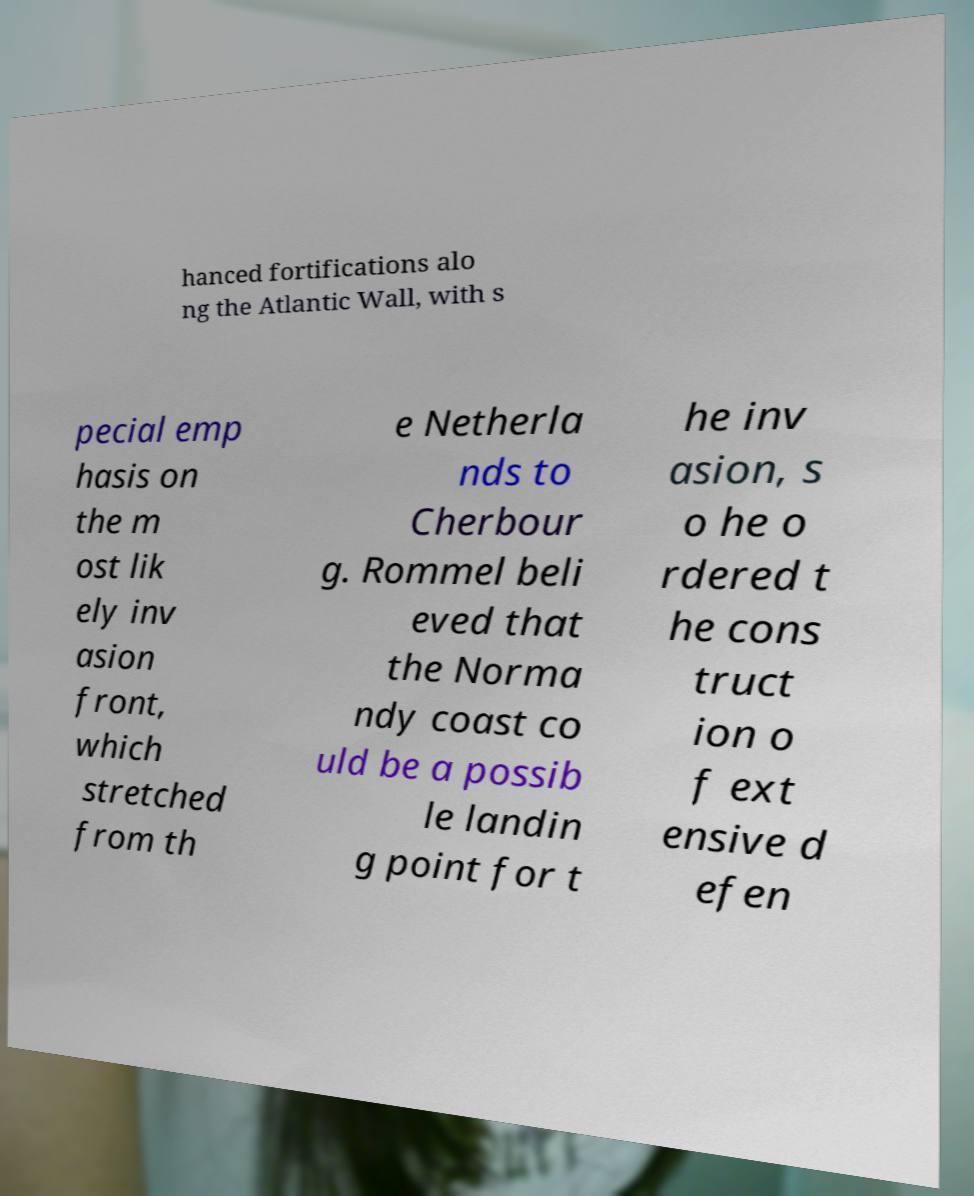Can you accurately transcribe the text from the provided image for me? hanced fortifications alo ng the Atlantic Wall, with s pecial emp hasis on the m ost lik ely inv asion front, which stretched from th e Netherla nds to Cherbour g. Rommel beli eved that the Norma ndy coast co uld be a possib le landin g point for t he inv asion, s o he o rdered t he cons truct ion o f ext ensive d efen 